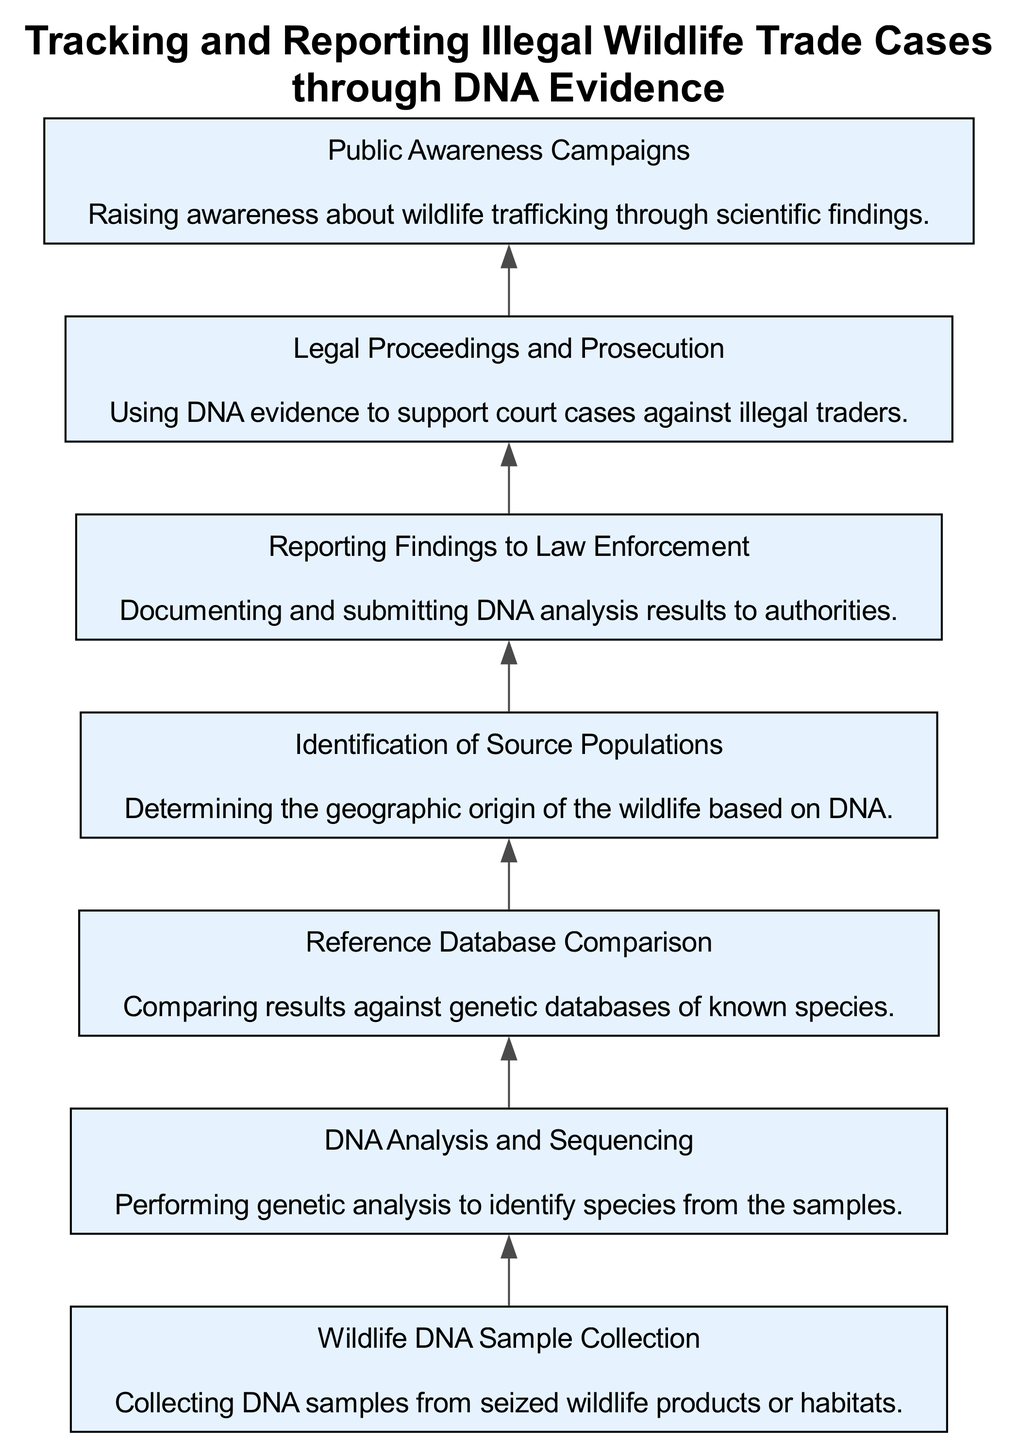What is the first step in the flow chart? The first element listed is "Wildlife DNA Sample Collection," which is the initial action taken in the process.
Answer: Wildlife DNA Sample Collection How many total elements are present in the flow chart? There are six elements in the flow chart, each representing a specific step in tracking and reporting illegal wildlife trade cases through DNA evidence.
Answer: Six Which element is responsible for comparing results against genetic databases? The "Reference Database Comparison" element is where the comparison against known genetic databases occurs.
Answer: Reference Database Comparison What follows the "DNA Analysis and Sequencing" in the flow chart? The "Reference Database Comparison" directly follows "DNA Analysis and Sequencing," indicating that once analysis is done, the results are compared.
Answer: Reference Database Comparison How many elements lead to legal action? There are two elements that lead to legal action: "Reporting Findings to Law Enforcement" and "Legal Proceedings and Prosecution."
Answer: Two What is the purpose of "Public Awareness Campaigns" in the flow chart? The purpose of "Public Awareness Campaigns" is to raise awareness about wildlife trafficking using scientific findings, showing its culmination role in the process.
Answer: Raise awareness Which element determines the geographic origin of wildlife? The "Identification of Source Populations" element is responsible for determining where the wildlife originated based on DNA analysis.
Answer: Identification of Source Populations What is the final result of the process outlined in the flow chart? The final result is "Legal Proceedings and Prosecution," where DNA evidence is utilized in court cases against illegal traders.
Answer: Legal Proceedings and Prosecution Which step involves documentation and submission of analysis results? The step that involves documenting and submitting DNA analysis results to authorities is "Reporting Findings to Law Enforcement."
Answer: Reporting Findings to Law Enforcement 